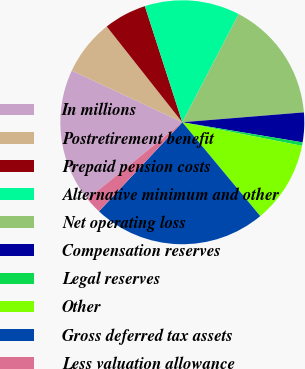<chart> <loc_0><loc_0><loc_500><loc_500><pie_chart><fcel>In millions<fcel>Postretirement benefit<fcel>Prepaid pension costs<fcel>Alternative minimum and other<fcel>Net operating loss<fcel>Compensation reserves<fcel>Legal reserves<fcel>Other<fcel>Gross deferred tax assets<fcel>Less valuation allowance<nl><fcel>17.8%<fcel>7.4%<fcel>5.67%<fcel>12.6%<fcel>16.07%<fcel>3.93%<fcel>0.46%<fcel>10.87%<fcel>23.0%<fcel>2.2%<nl></chart> 